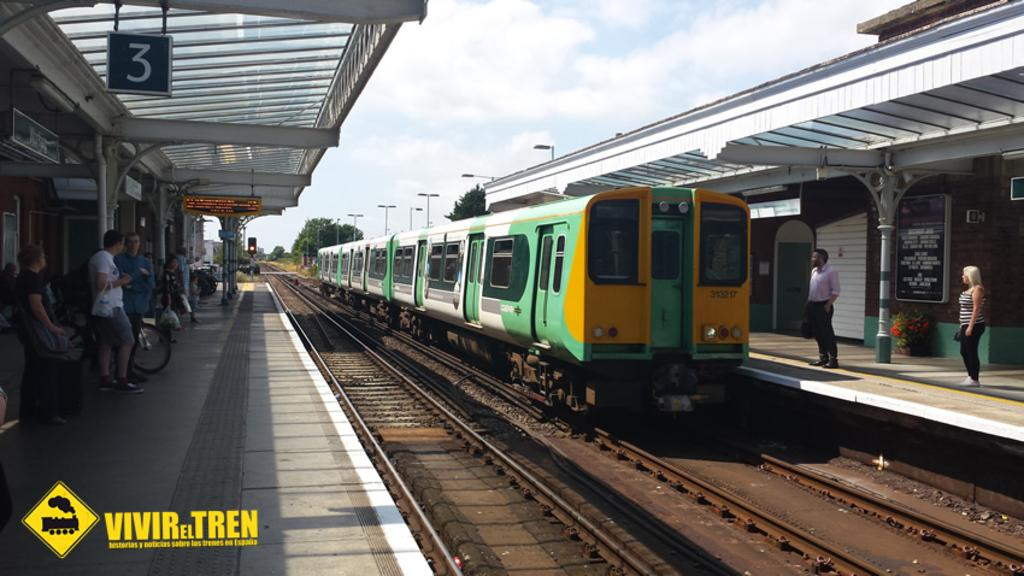<image>
Describe the image concisely. A picture of a green and yellow train with the logo VIVIR EL TREN in the bottom left corner 